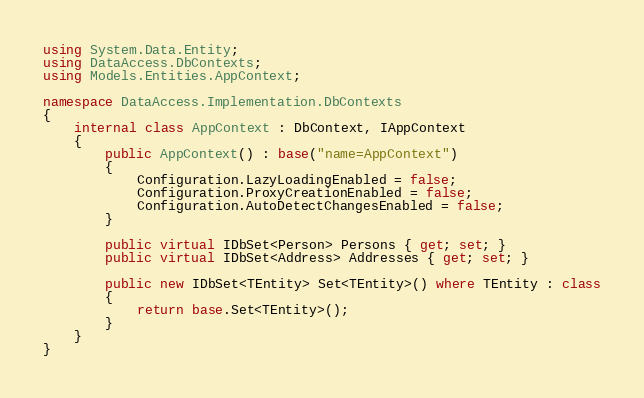<code> <loc_0><loc_0><loc_500><loc_500><_C#_>using System.Data.Entity;
using DataAccess.DbContexts;
using Models.Entities.AppContext;

namespace DataAccess.Implementation.DbContexts
{
    internal class AppContext : DbContext, IAppContext
    {
        public AppContext() : base("name=AppContext")
        {
            Configuration.LazyLoadingEnabled = false;
            Configuration.ProxyCreationEnabled = false;
            Configuration.AutoDetectChangesEnabled = false;
        }

        public virtual IDbSet<Person> Persons { get; set; }
        public virtual IDbSet<Address> Addresses { get; set; }

        public new IDbSet<TEntity> Set<TEntity>() where TEntity : class
        {
            return base.Set<TEntity>();
        }
    }
}</code> 